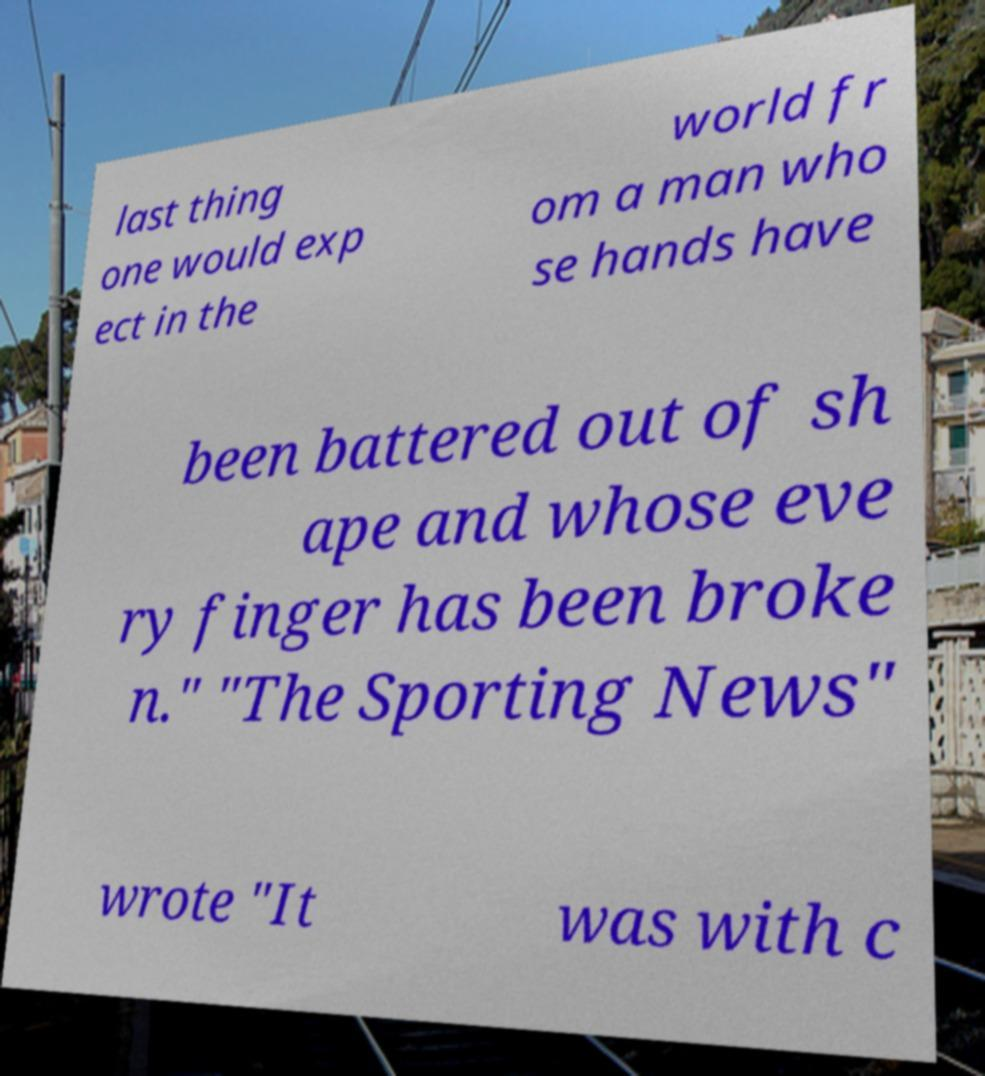Could you assist in decoding the text presented in this image and type it out clearly? last thing one would exp ect in the world fr om a man who se hands have been battered out of sh ape and whose eve ry finger has been broke n." "The Sporting News" wrote "It was with c 